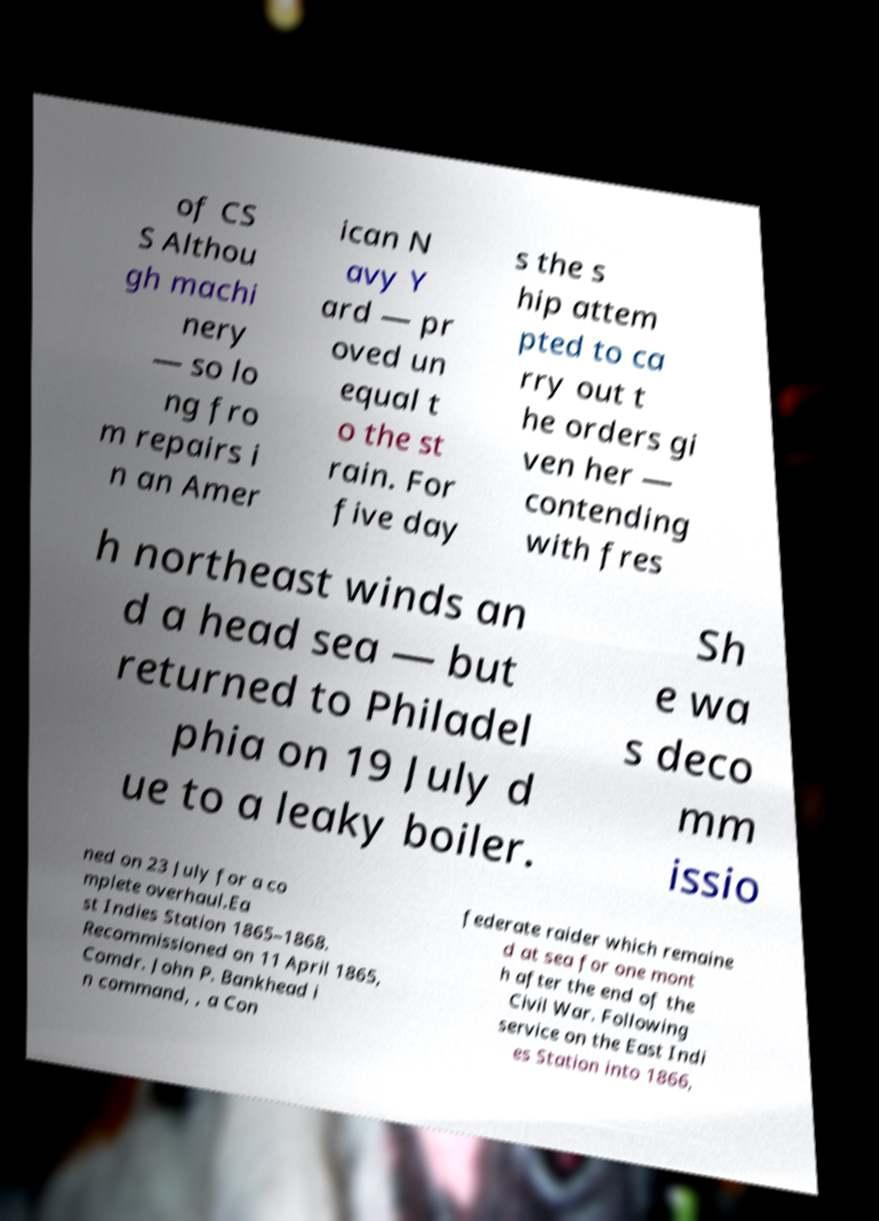Please read and relay the text visible in this image. What does it say? of CS S Althou gh machi nery — so lo ng fro m repairs i n an Amer ican N avy Y ard — pr oved un equal t o the st rain. For five day s the s hip attem pted to ca rry out t he orders gi ven her — contending with fres h northeast winds an d a head sea — but returned to Philadel phia on 19 July d ue to a leaky boiler. Sh e wa s deco mm issio ned on 23 July for a co mplete overhaul.Ea st Indies Station 1865–1868. Recommissioned on 11 April 1865, Comdr. John P. Bankhead i n command, , a Con federate raider which remaine d at sea for one mont h after the end of the Civil War. Following service on the East Indi es Station into 1866, 